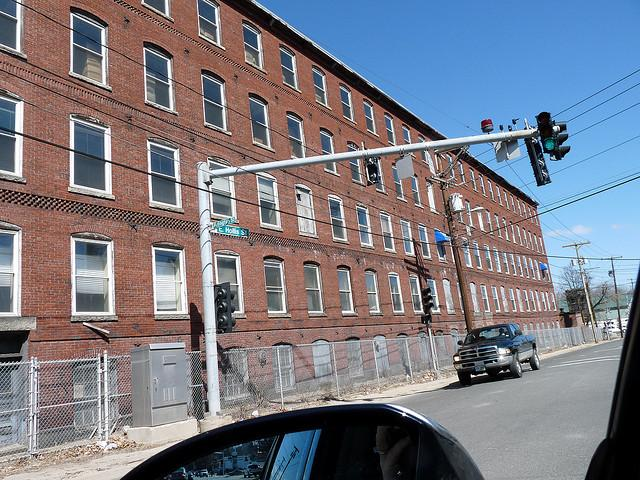What should the vehicle showing the side mirror do in this situation?

Choices:
A) turn right
B) turn left
C) stop
D) go go 